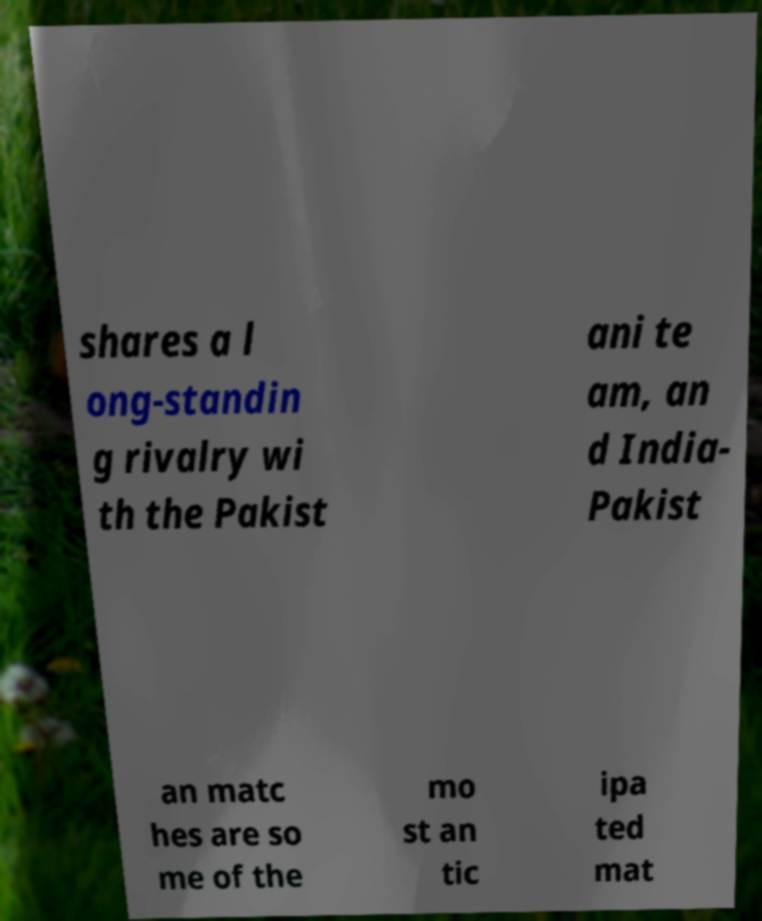There's text embedded in this image that I need extracted. Can you transcribe it verbatim? shares a l ong-standin g rivalry wi th the Pakist ani te am, an d India- Pakist an matc hes are so me of the mo st an tic ipa ted mat 